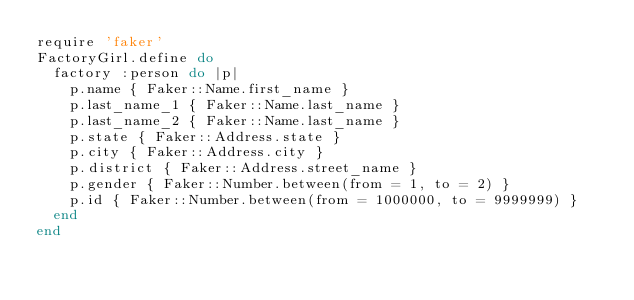<code> <loc_0><loc_0><loc_500><loc_500><_Ruby_>require 'faker'
FactoryGirl.define do
  factory :person do |p|
    p.name { Faker::Name.first_name }
    p.last_name_1 { Faker::Name.last_name }
    p.last_name_2 { Faker::Name.last_name }
    p.state { Faker::Address.state }
    p.city { Faker::Address.city }
    p.district { Faker::Address.street_name }
    p.gender { Faker::Number.between(from = 1, to = 2) }
    p.id { Faker::Number.between(from = 1000000, to = 9999999) }
  end
end
</code> 